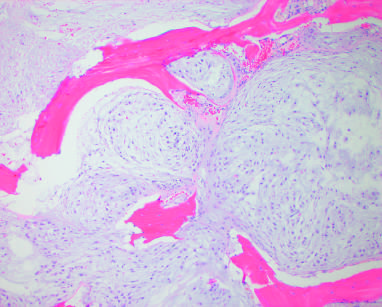does conventional chondrosarcoma entrap native lamellar bone as a confluent mass of cartilage?
Answer the question using a single word or phrase. Yes 